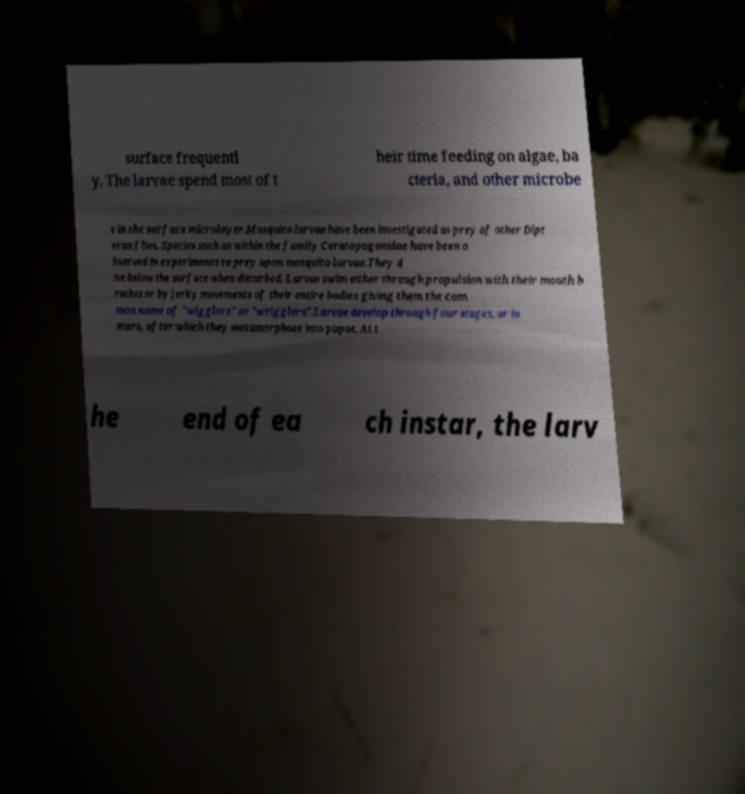Could you extract and type out the text from this image? surface frequentl y. The larvae spend most of t heir time feeding on algae, ba cteria, and other microbe s in the surface microlayer.Mosquito larvae have been investigated as prey of other Dipt eran flies. Species such as within the family Ceratopogonidae have been o bserved in experiments to prey upon mosquito larvae.They d ive below the surface when disturbed. Larvae swim either through propulsion with their mouth b rushes or by jerky movements of their entire bodies giving them the com mon name of "wigglers" or "wrigglers".Larvae develop through four stages, or in stars, after which they metamorphose into pupae. At t he end of ea ch instar, the larv 